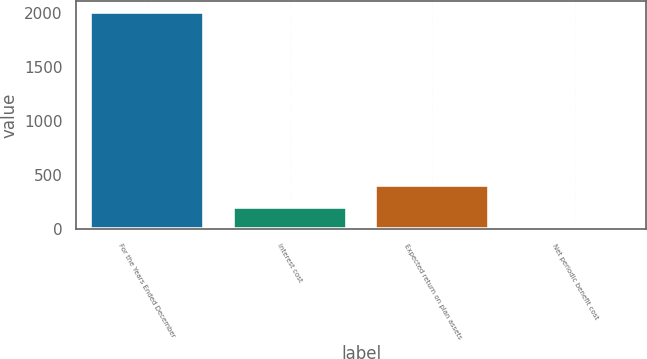<chart> <loc_0><loc_0><loc_500><loc_500><bar_chart><fcel>For the Years Ended December<fcel>Interest cost<fcel>Expected return on plan assets<fcel>Net periodic benefit cost<nl><fcel>2013<fcel>209.04<fcel>409.48<fcel>8.6<nl></chart> 